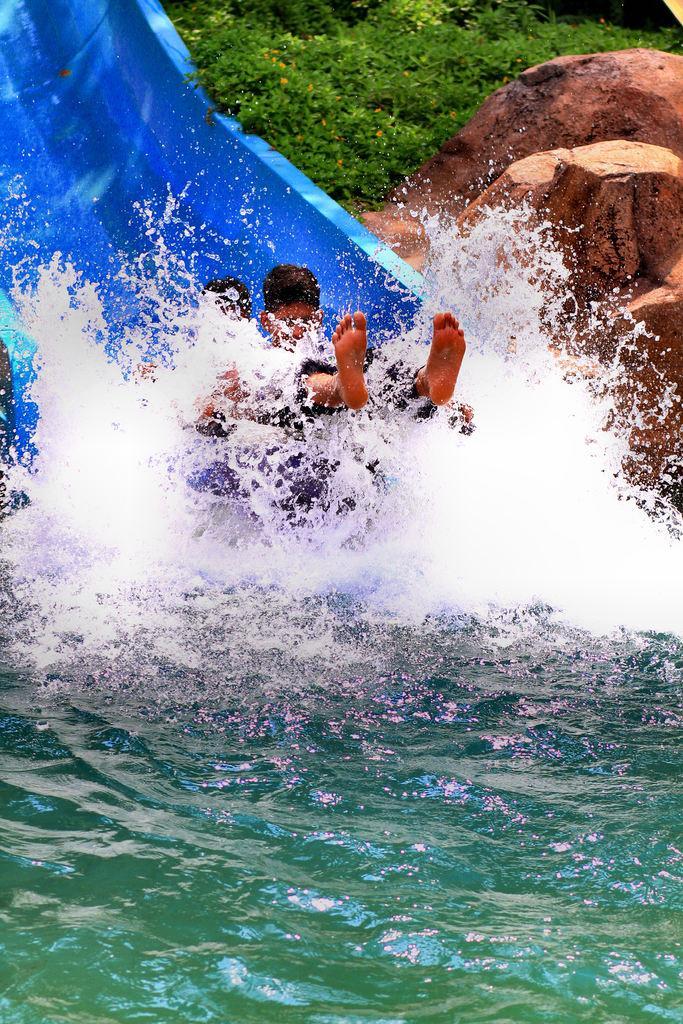Can you describe this image briefly? In the center of the image we can see people on the slide. At the bottom there is water. In the background there are rocks and trees. 